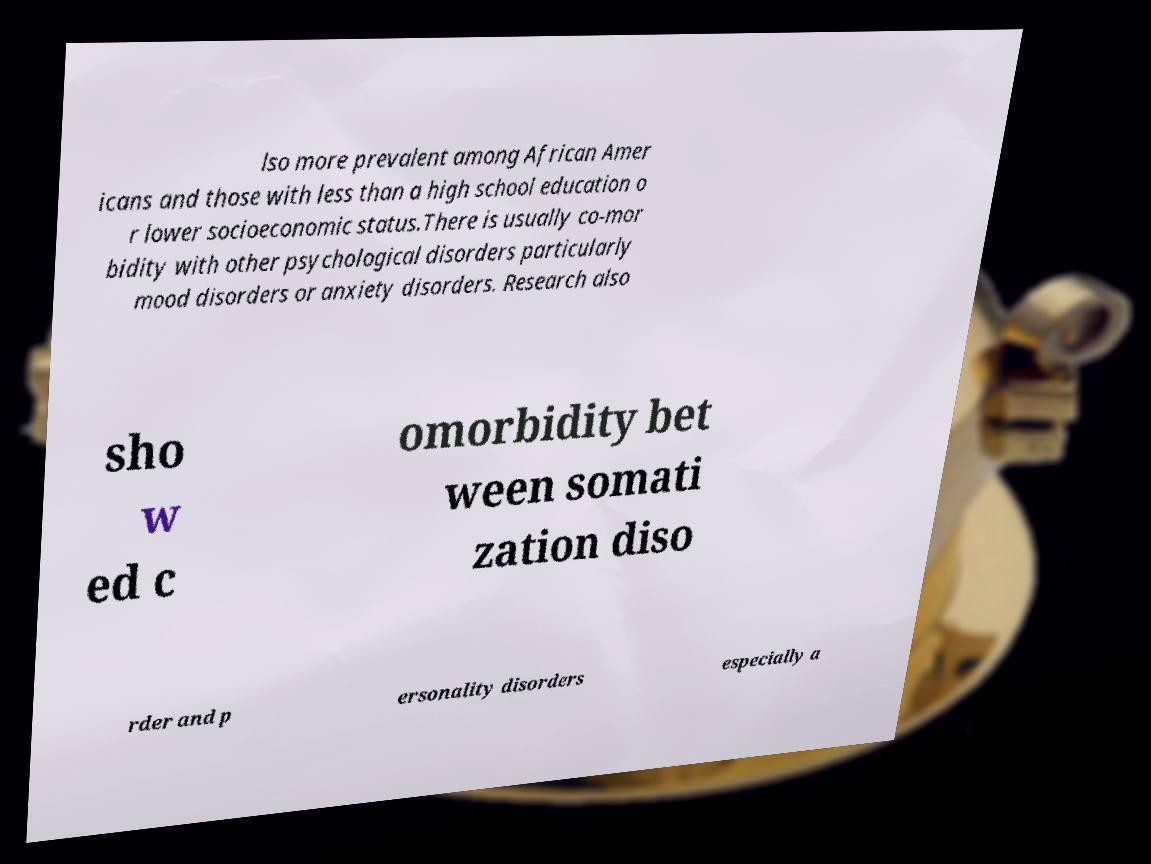There's text embedded in this image that I need extracted. Can you transcribe it verbatim? lso more prevalent among African Amer icans and those with less than a high school education o r lower socioeconomic status.There is usually co-mor bidity with other psychological disorders particularly mood disorders or anxiety disorders. Research also sho w ed c omorbidity bet ween somati zation diso rder and p ersonality disorders especially a 